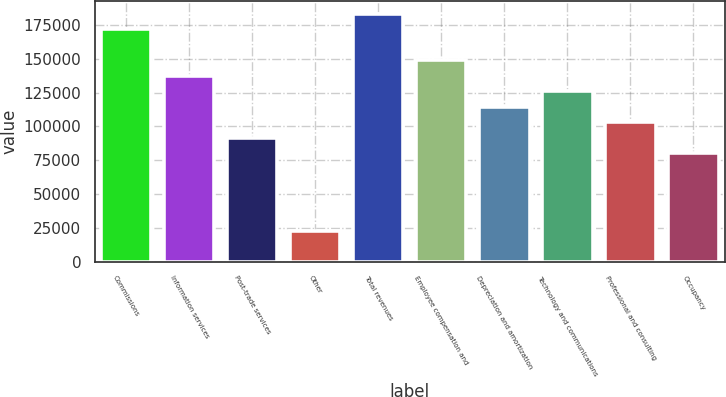Convert chart to OTSL. <chart><loc_0><loc_0><loc_500><loc_500><bar_chart><fcel>Commissions<fcel>Information services<fcel>Post-trade services<fcel>Other<fcel>Total revenues<fcel>Employee compensation and<fcel>Depreciation and amortization<fcel>Technology and communications<fcel>Professional and consulting<fcel>Occupancy<nl><fcel>172070<fcel>137657<fcel>91771.4<fcel>22943.8<fcel>183542<fcel>149128<fcel>114714<fcel>126185<fcel>103243<fcel>80300.2<nl></chart> 